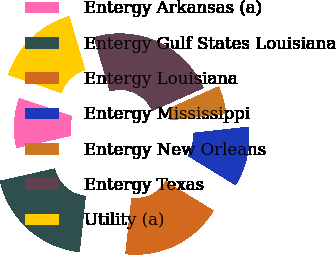<chart> <loc_0><loc_0><loc_500><loc_500><pie_chart><fcel>Entergy Arkansas (a)<fcel>Entergy Gulf States Louisiana<fcel>Entergy Louisiana<fcel>Entergy Mississippi<fcel>Entergy New Orleans<fcel>Entergy Texas<fcel>Utility (a)<nl><fcel>8.71%<fcel>19.77%<fcel>17.97%<fcel>10.51%<fcel>4.9%<fcel>22.88%<fcel>15.25%<nl></chart> 